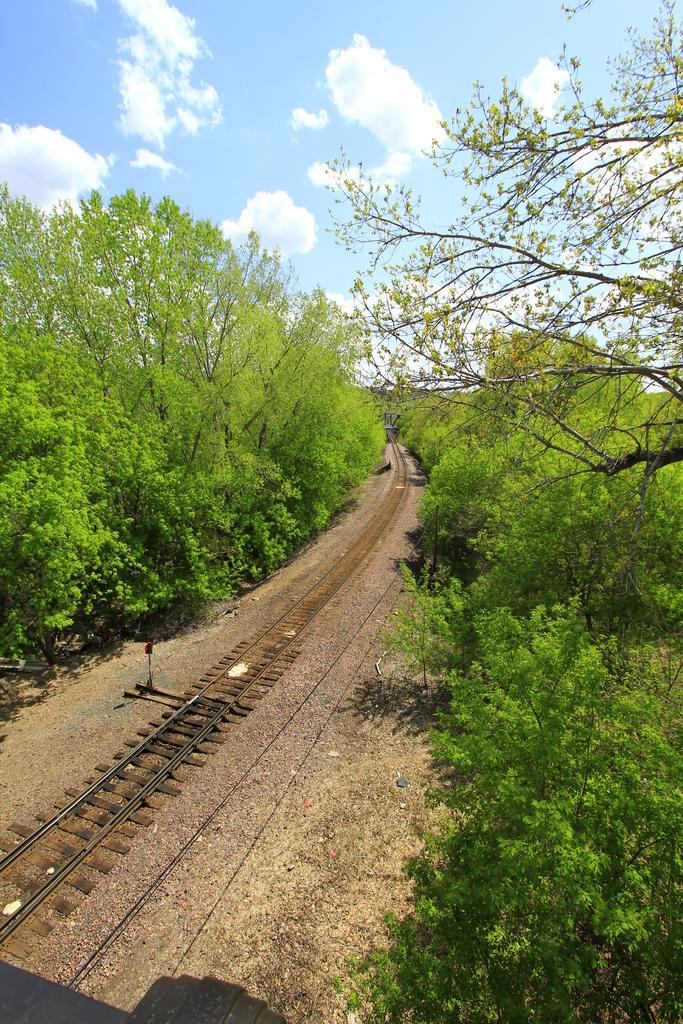What type of transportation infrastructure is present in the image? There is a railway track in the image. What type of vegetation can be seen in the image? There are green trees in the image. What color is the sky in the image? The sky is blue in the image. What can be seen in the sky in the image? There are clouds visible in the image. How many socks are hanging on the trees in the image? There are no socks present in the image; it features a railway track, green trees, a blue sky, and clouds. 